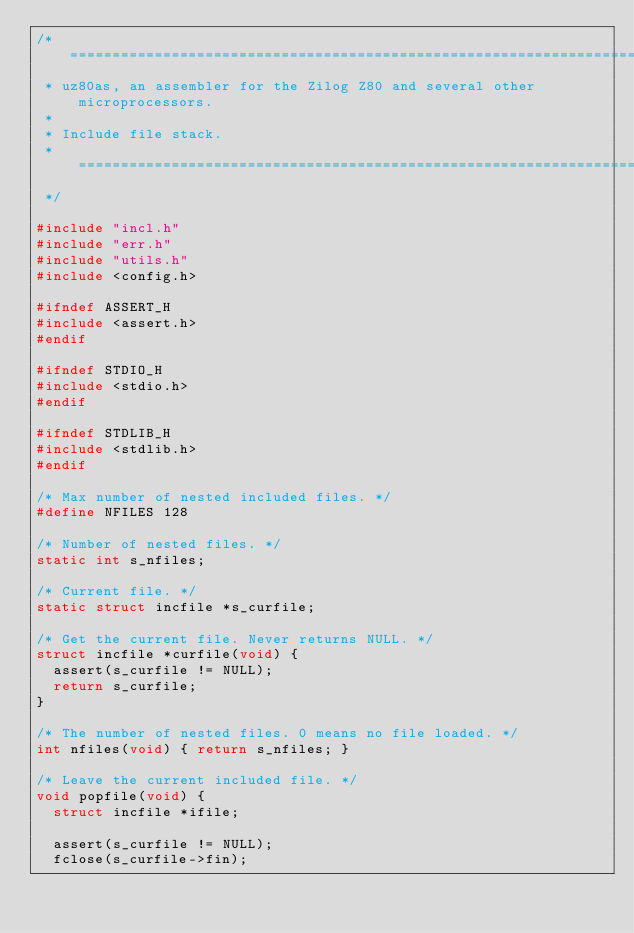Convert code to text. <code><loc_0><loc_0><loc_500><loc_500><_C_>/* ===========================================================================
 * uz80as, an assembler for the Zilog Z80 and several other microprocessors.
 *
 * Include file stack.
 * ===========================================================================
 */

#include "incl.h"
#include "err.h"
#include "utils.h"
#include <config.h>

#ifndef ASSERT_H
#include <assert.h>
#endif

#ifndef STDIO_H
#include <stdio.h>
#endif

#ifndef STDLIB_H
#include <stdlib.h>
#endif

/* Max number of nested included files. */
#define NFILES 128

/* Number of nested files. */
static int s_nfiles;

/* Current file. */
static struct incfile *s_curfile;

/* Get the current file. Never returns NULL. */
struct incfile *curfile(void) {
  assert(s_curfile != NULL);
  return s_curfile;
}

/* The number of nested files. 0 means no file loaded. */
int nfiles(void) { return s_nfiles; }

/* Leave the current included file. */
void popfile(void) {
  struct incfile *ifile;

  assert(s_curfile != NULL);
  fclose(s_curfile->fin);</code> 